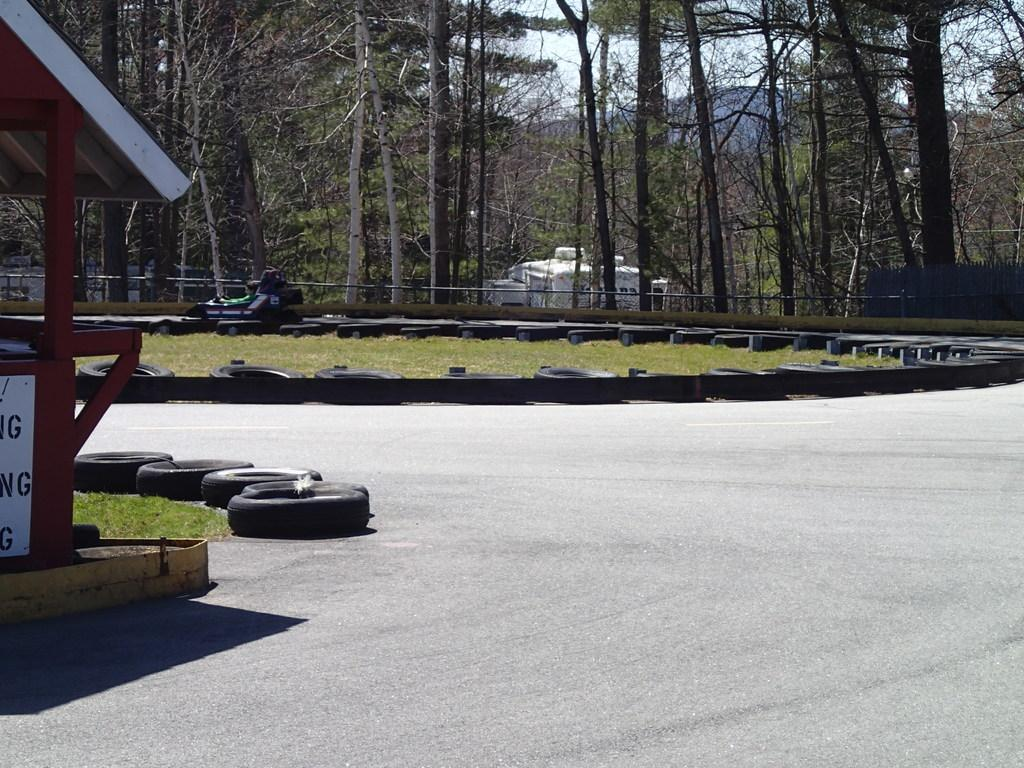What is the main subject of the picture? The main subject of the picture is a go-karting area. What can be seen in the background of the image? There are tall trees behind the go-karting area. What type of food is being served at the go-karting area in the image? There is no food visible in the image, as it focuses on the go-karting area and the tall trees in the background. 